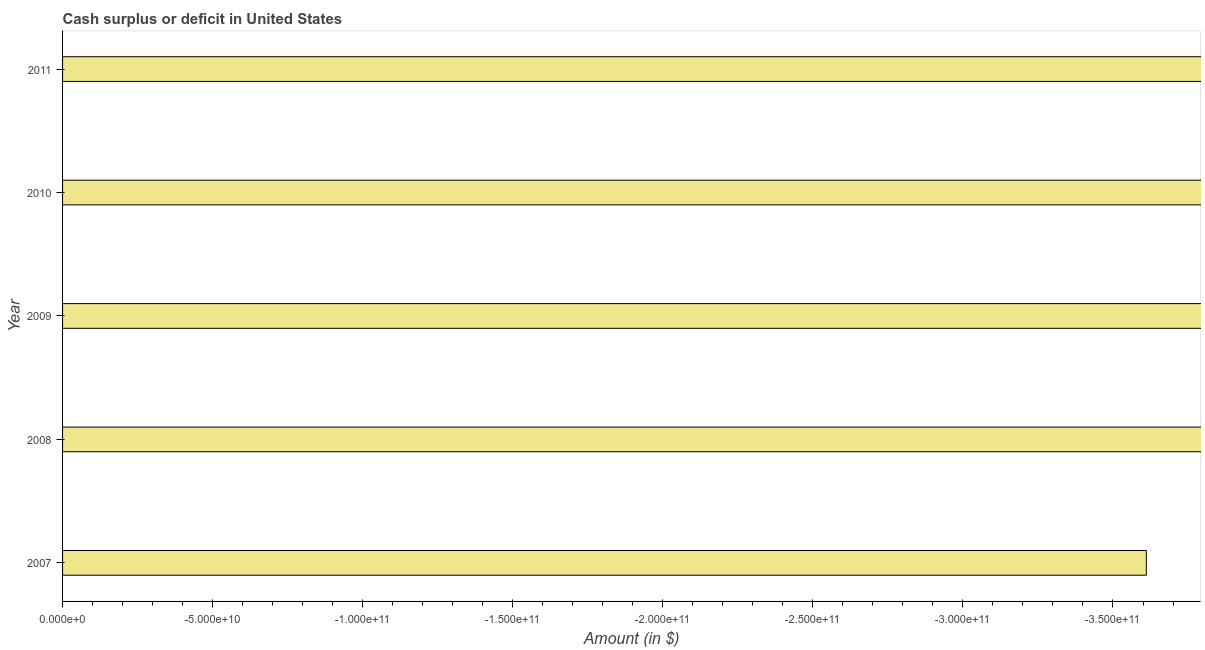What is the title of the graph?
Ensure brevity in your answer.  Cash surplus or deficit in United States. What is the label or title of the X-axis?
Your answer should be very brief. Amount (in $). What is the label or title of the Y-axis?
Provide a succinct answer. Year. What is the median cash surplus or deficit?
Your response must be concise. 0. In how many years, is the cash surplus or deficit greater than -210000000000 $?
Ensure brevity in your answer.  0. In how many years, is the cash surplus or deficit greater than the average cash surplus or deficit taken over all years?
Your answer should be compact. 0. How many bars are there?
Your answer should be compact. 0. Are all the bars in the graph horizontal?
Your response must be concise. Yes. How many years are there in the graph?
Offer a very short reply. 5. What is the Amount (in $) in 2007?
Your answer should be very brief. 0. 